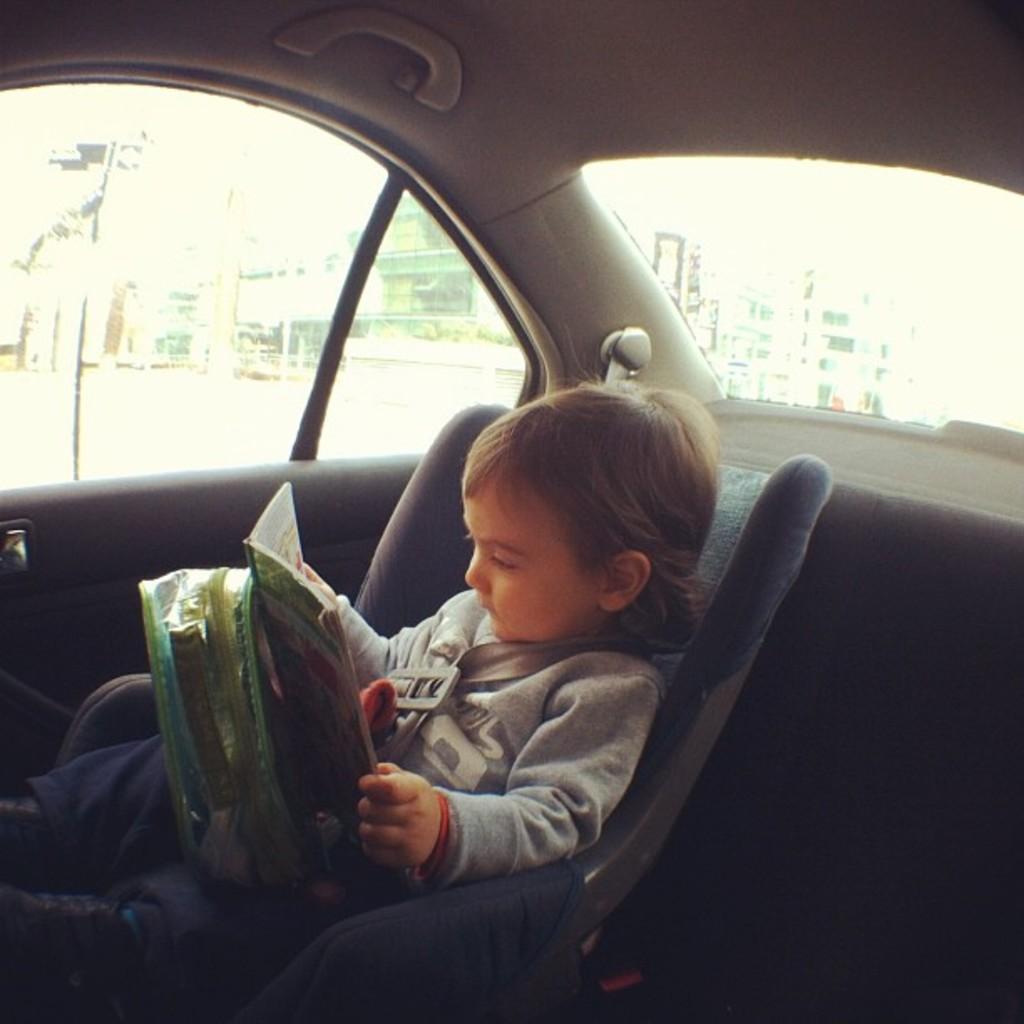How would you summarize this image in a sentence or two? As we can see in the image there is a building, traffic signal and a child sitting in car. The child is holding a book and a bag. 